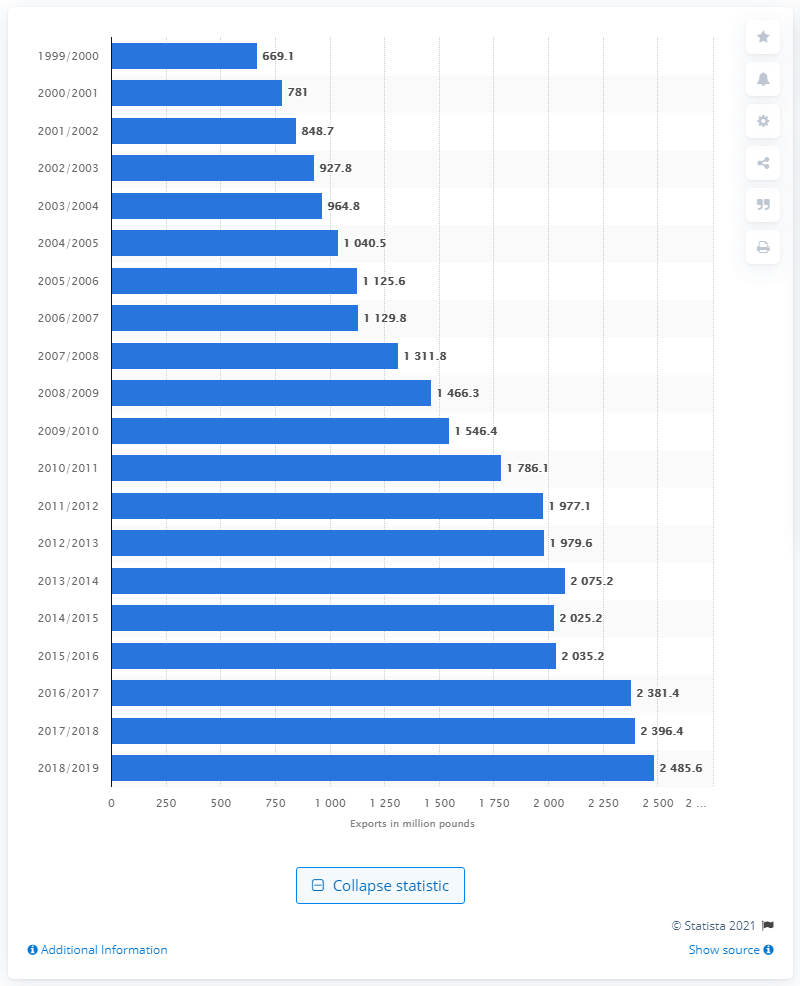Give some essential details in this illustration. The total amount of tree nut exports in the United States in 2015/2016 was approximately 202.52 million dollars. 